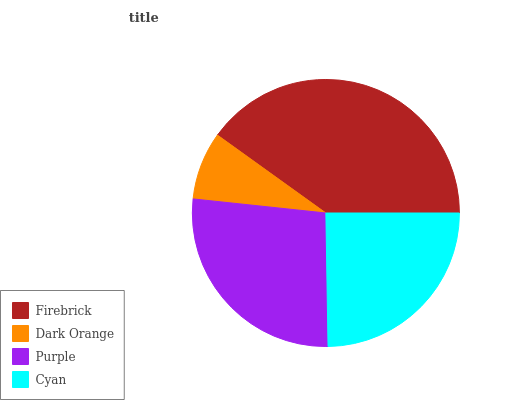Is Dark Orange the minimum?
Answer yes or no. Yes. Is Firebrick the maximum?
Answer yes or no. Yes. Is Purple the minimum?
Answer yes or no. No. Is Purple the maximum?
Answer yes or no. No. Is Purple greater than Dark Orange?
Answer yes or no. Yes. Is Dark Orange less than Purple?
Answer yes or no. Yes. Is Dark Orange greater than Purple?
Answer yes or no. No. Is Purple less than Dark Orange?
Answer yes or no. No. Is Purple the high median?
Answer yes or no. Yes. Is Cyan the low median?
Answer yes or no. Yes. Is Firebrick the high median?
Answer yes or no. No. Is Purple the low median?
Answer yes or no. No. 